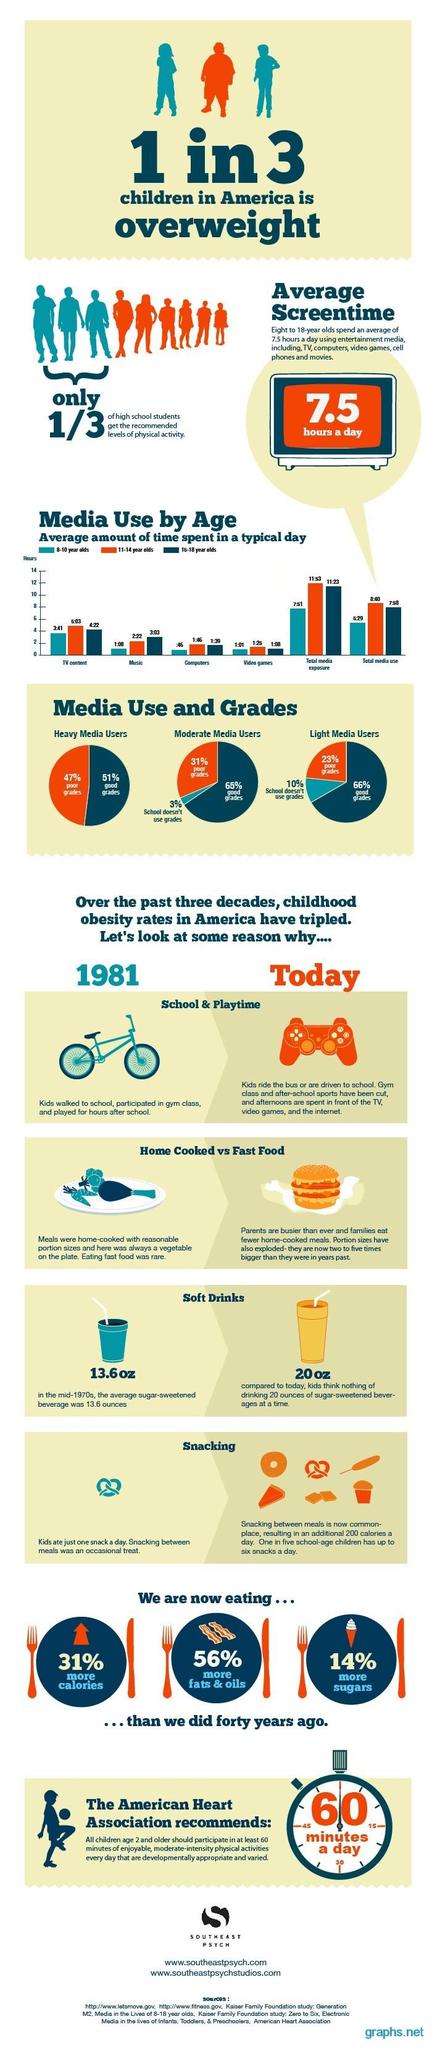Give some essential details in this illustration. According to research, 8 to 18-year-olds on average spend 52.5 hours per week using entertainment media. According to data, only 33.33% of high school students achieve the recommended levels of physical activity. According to recent statistics, it is estimated that approximately 33.33% of children in America are overweight. The color orange is associated with poor grades in a pie chart. According to data, children aged 8-18 who belong to the age group of 11-14 years spend the most amount of time engaging in TV content. 